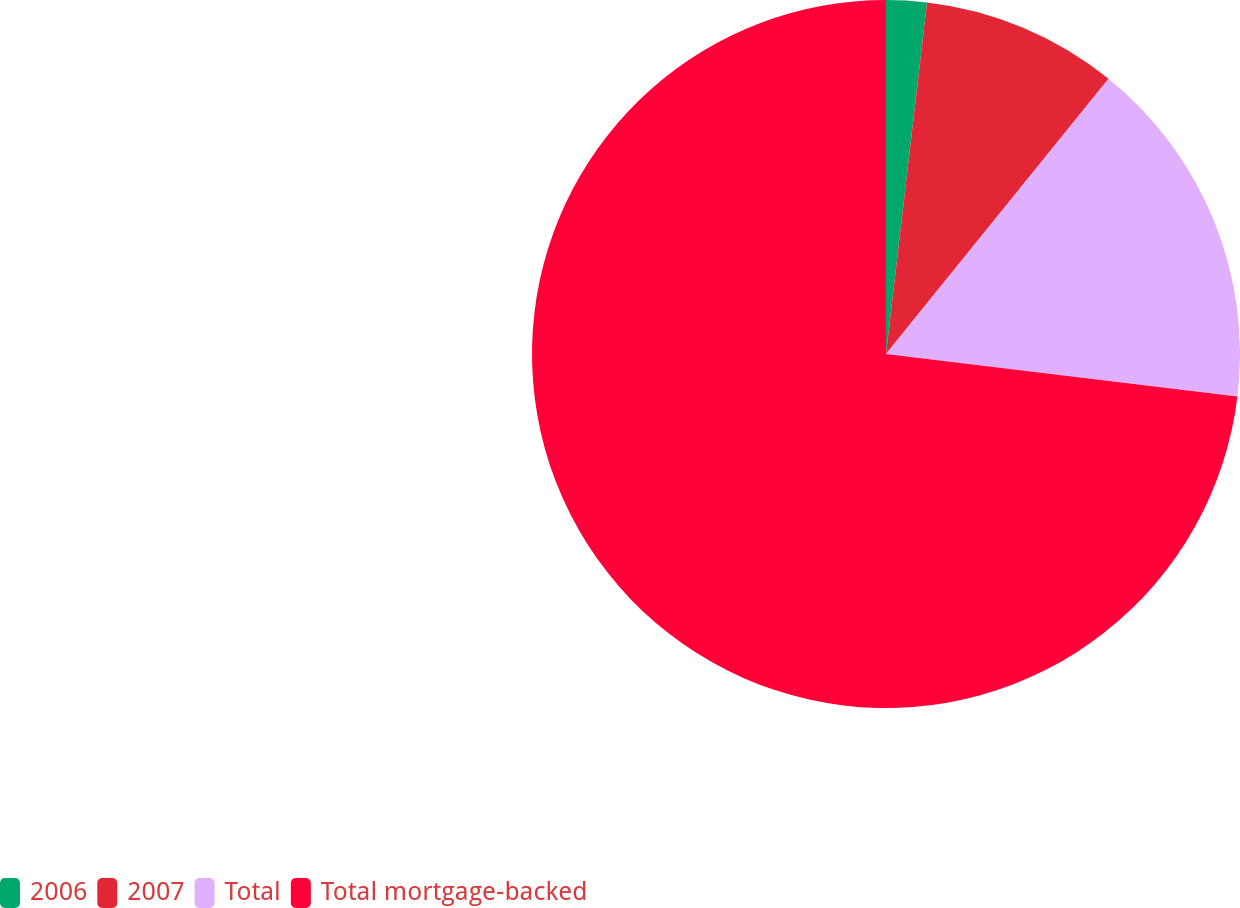Convert chart. <chart><loc_0><loc_0><loc_500><loc_500><pie_chart><fcel>2006<fcel>2007<fcel>Total<fcel>Total mortgage-backed<nl><fcel>1.85%<fcel>8.97%<fcel>16.1%<fcel>73.08%<nl></chart> 